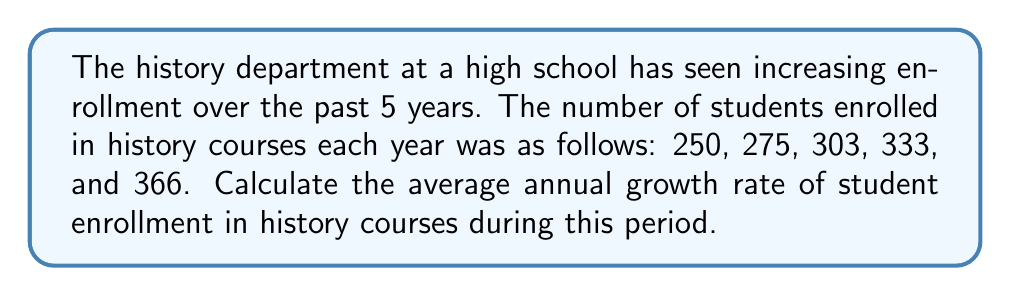What is the answer to this math problem? To calculate the average annual growth rate, we'll use the compound annual growth rate (CAGR) formula:

$$ CAGR = \left(\frac{Ending Value}{Beginning Value}\right)^{\frac{1}{n}} - 1 $$

Where:
- Ending Value is the final year's enrollment (366)
- Beginning Value is the first year's enrollment (250)
- n is the number of years (5)

Step 1: Insert the values into the formula
$$ CAGR = \left(\frac{366}{250}\right)^{\frac{1}{5}} - 1 $$

Step 2: Calculate the value inside the parentheses
$$ CAGR = (1.464)^{\frac{1}{5}} - 1 $$

Step 3: Calculate the fifth root
$$ CAGR = 1.0793 - 1 $$

Step 4: Subtract 1 to get the growth rate
$$ CAGR = 0.0793 $$

Step 5: Convert to a percentage
$$ CAGR = 7.93\% $$

Therefore, the average annual growth rate of student enrollment in history courses over the 5-year period was 7.93%.
Answer: 7.93% 